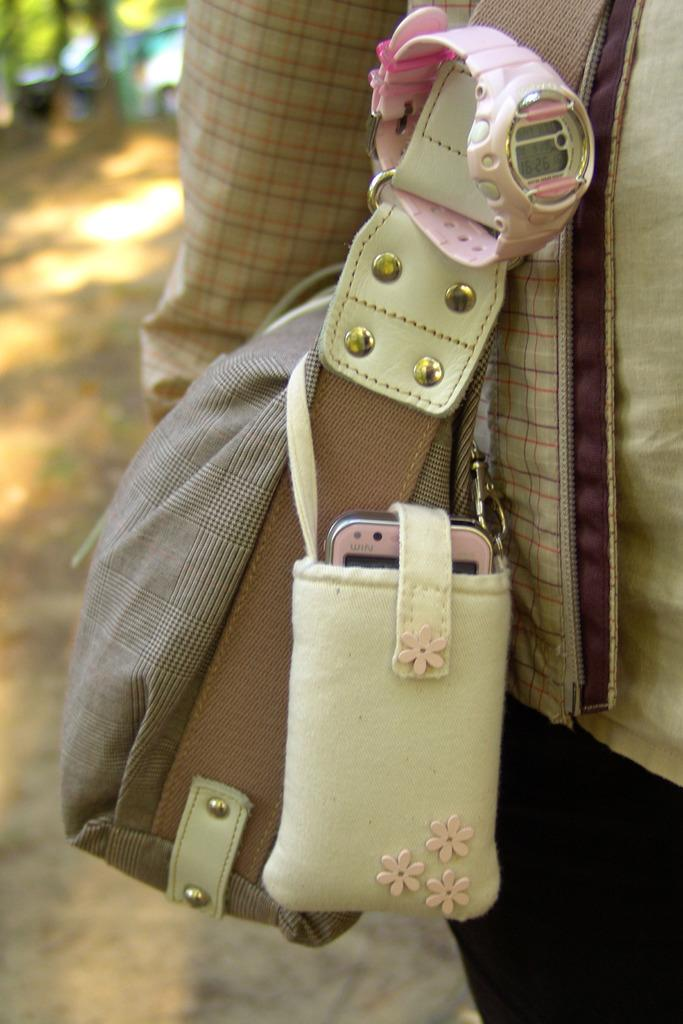What is the person holding in the image? The person is holding a handbag. What items are inside the handbag? The handbag contains a watch, a phone, and a pouch. What is inside the pouch within the handbag? The pouch contains a mobile. What store can be seen in the background of the image? There is no store visible in the image; it only shows a person holding a handbag. 